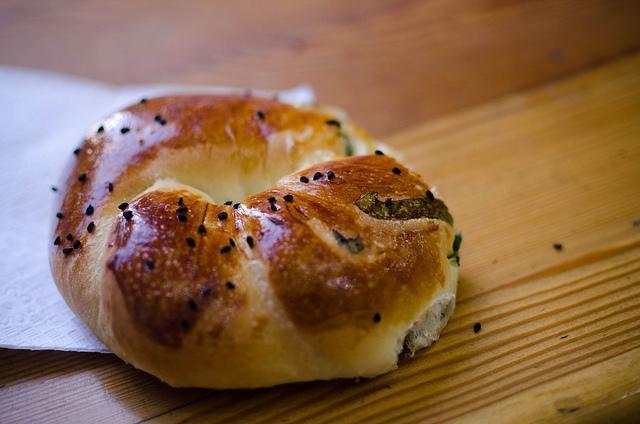How many necklaces is the man wearing?
Give a very brief answer. 0. 